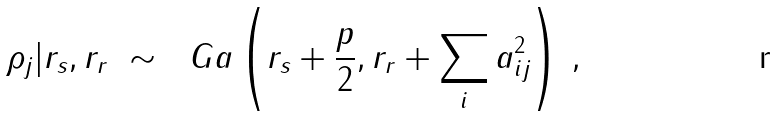<formula> <loc_0><loc_0><loc_500><loc_500>\rho _ { j } | r _ { s } , r _ { r } \ \sim \ \ G a \left ( r _ { s } + \frac { p } { 2 } , r _ { r } + \sum _ { i } a _ { i j } ^ { 2 } \right ) \, ,</formula> 